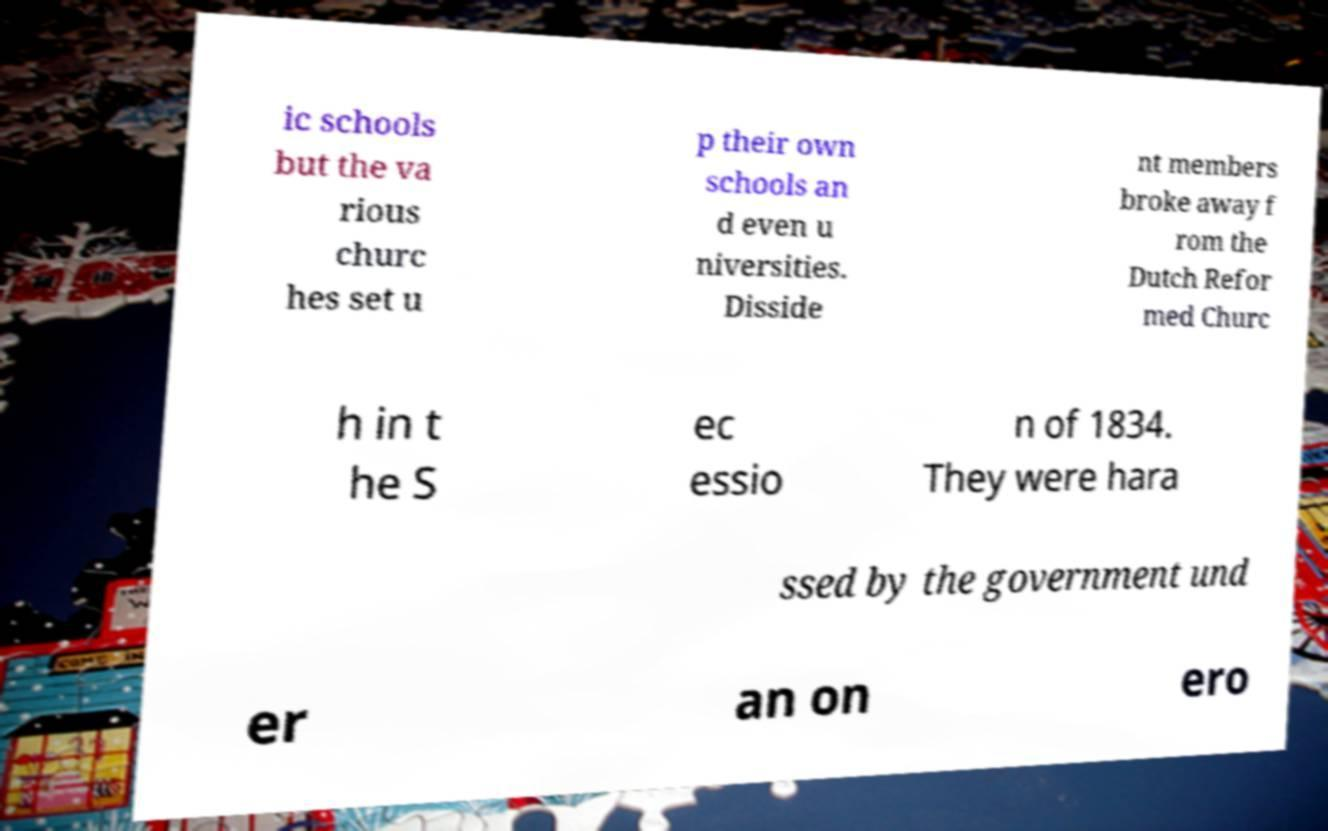Could you extract and type out the text from this image? ic schools but the va rious churc hes set u p their own schools an d even u niversities. Disside nt members broke away f rom the Dutch Refor med Churc h in t he S ec essio n of 1834. They were hara ssed by the government und er an on ero 